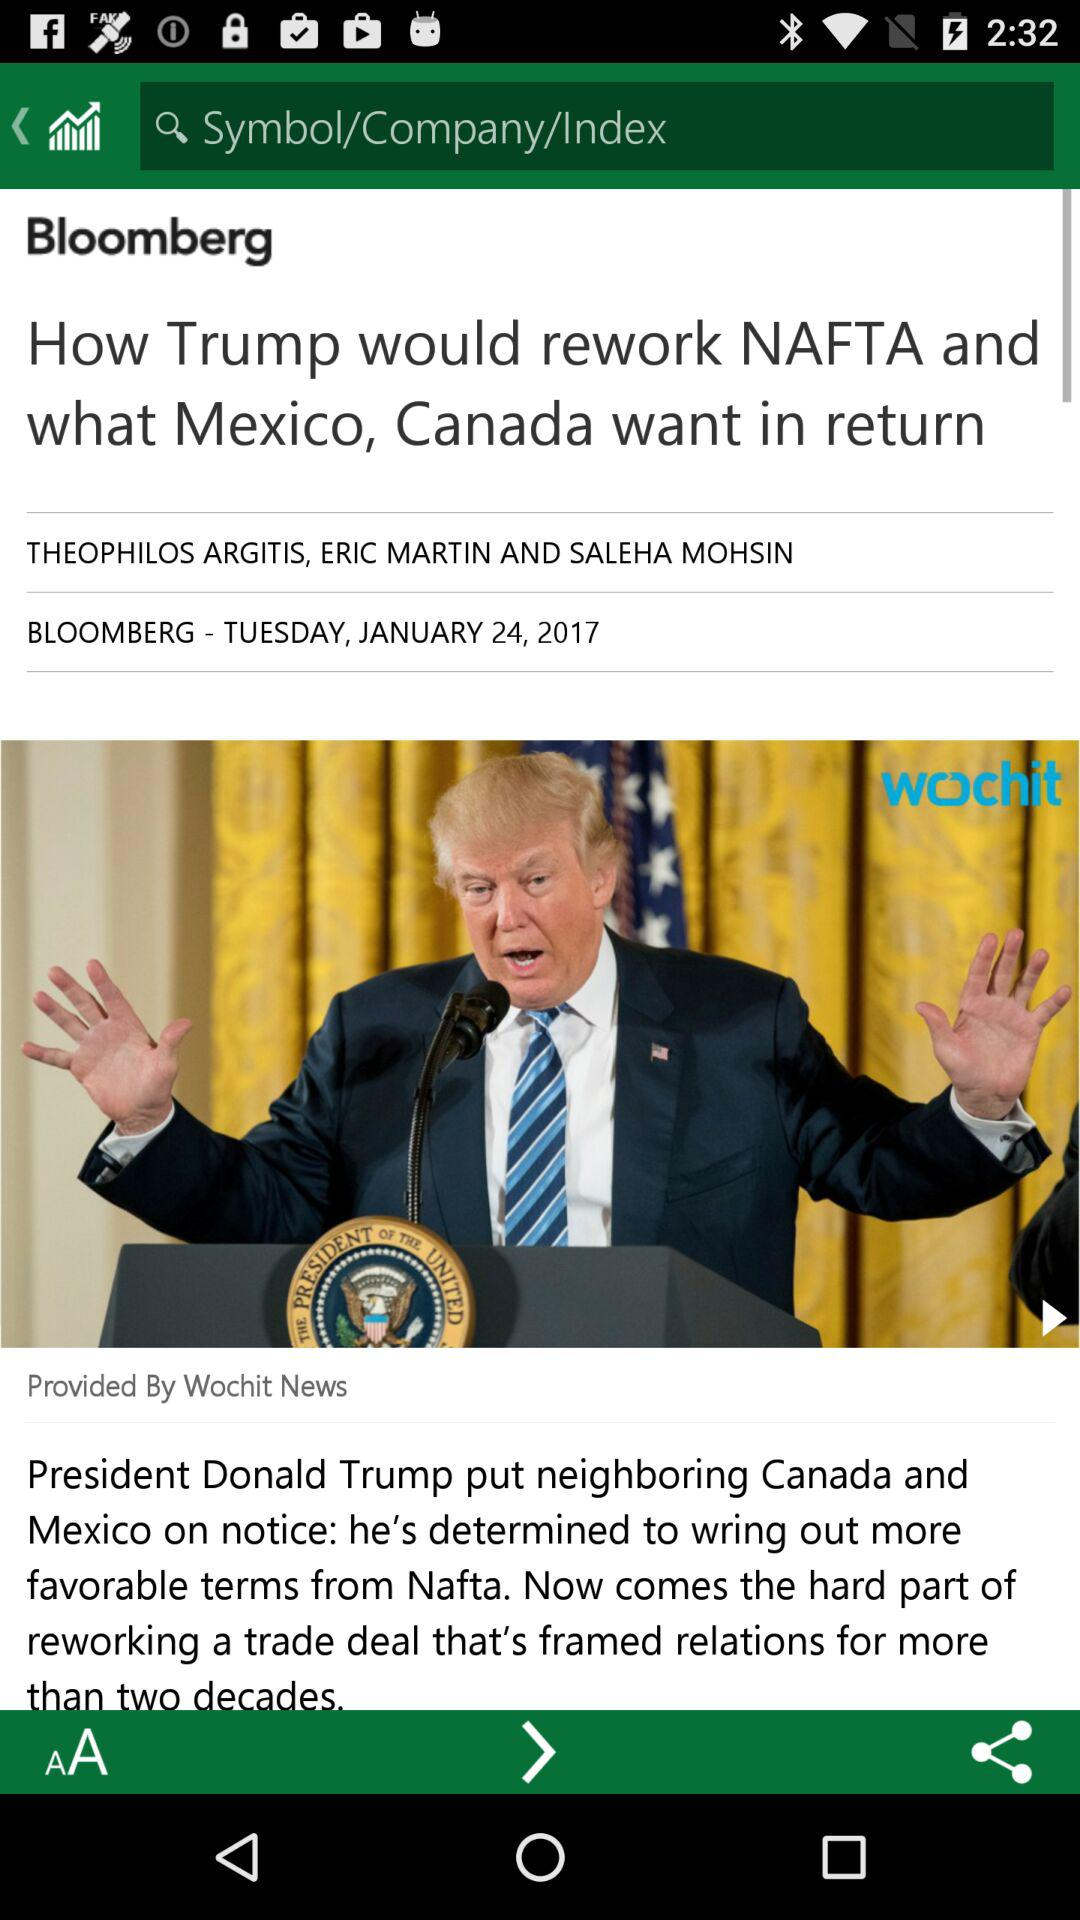What is the day of the article? The day of the article is Tuesday. 